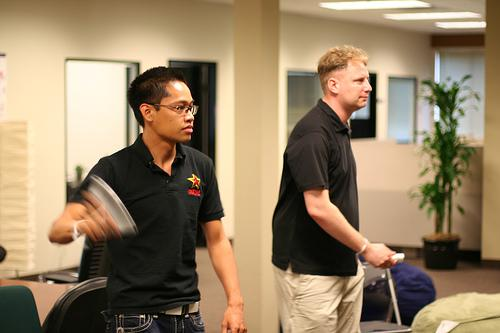Question: how many of the joysticks are there?
Choices:
A. One.
B. Two.
C. Zero.
D. Three.
Answer with the letter. Answer: B Question: where is the plant?
Choices:
A. By the door.
B. In the middle of the sidewalk.
C. A pot.
D. Around the pool.
Answer with the letter. Answer: C Question: how many people are shown?
Choices:
A. Three.
B. Four.
C. Five.
D. Two.
Answer with the letter. Answer: D Question: what are the people holding?
Choices:
A. Plates.
B. Joysticks.
C. Books.
D. Phones.
Answer with the letter. Answer: B Question: what are the people doing?
Choices:
A. Standing.
B. Eating.
C. Laughing.
D. Visiting tourist sites.
Answer with the letter. Answer: A 